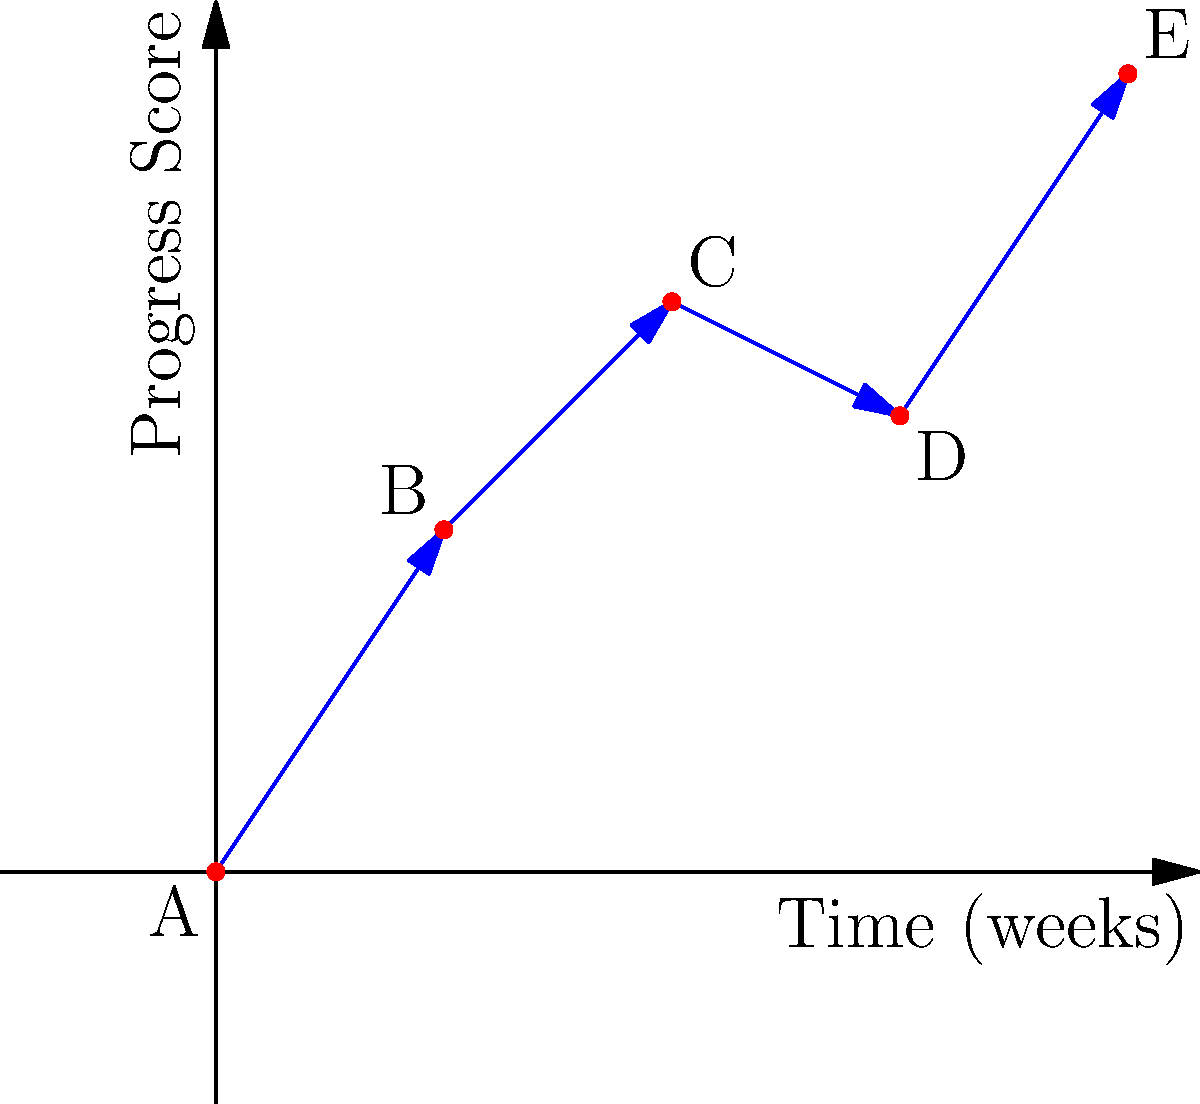In the graph above, patient progress is plotted over time using vector paths. Each vector represents the change in progress score between two consecutive time points. What is the total displacement vector from point A to point E, and what does this represent in terms of patient progress? To solve this problem, we'll follow these steps:

1. Identify the start and end points:
   - Start point A: (0,0)
   - End point E: (8,7)

2. Calculate the displacement vector:
   - The displacement vector is the difference between the end and start points.
   - Displacement = End point - Start point
   - Displacement = (8,7) - (0,0) = (8,7)

3. Interpret the displacement vector:
   - The x-component (8) represents the total time elapsed: 8 weeks
   - The y-component (7) represents the total change in progress score: 7 units

4. Calculate the magnitude of the displacement vector:
   - Magnitude = $\sqrt{x^2 + y^2} = \sqrt{8^2 + 7^2} = \sqrt{64 + 49} = \sqrt{113} \approx 10.63$

5. Interpret the result:
   - The magnitude represents the straight-line distance between the start and end points in the progress-time space.
   - This can be interpreted as the overall rate of progress: approximately 10.63 units of progress per 8 weeks, or 1.33 units per week on average.

In terms of patient progress, the displacement vector (8,7) indicates that over 8 weeks, the patient's progress score increased by 7 units. This represents a positive trend in the patient's progress, although the path shows some fluctuations (as seen in the individual vectors).
Answer: (8,7); overall positive progress of 7 units over 8 weeks 